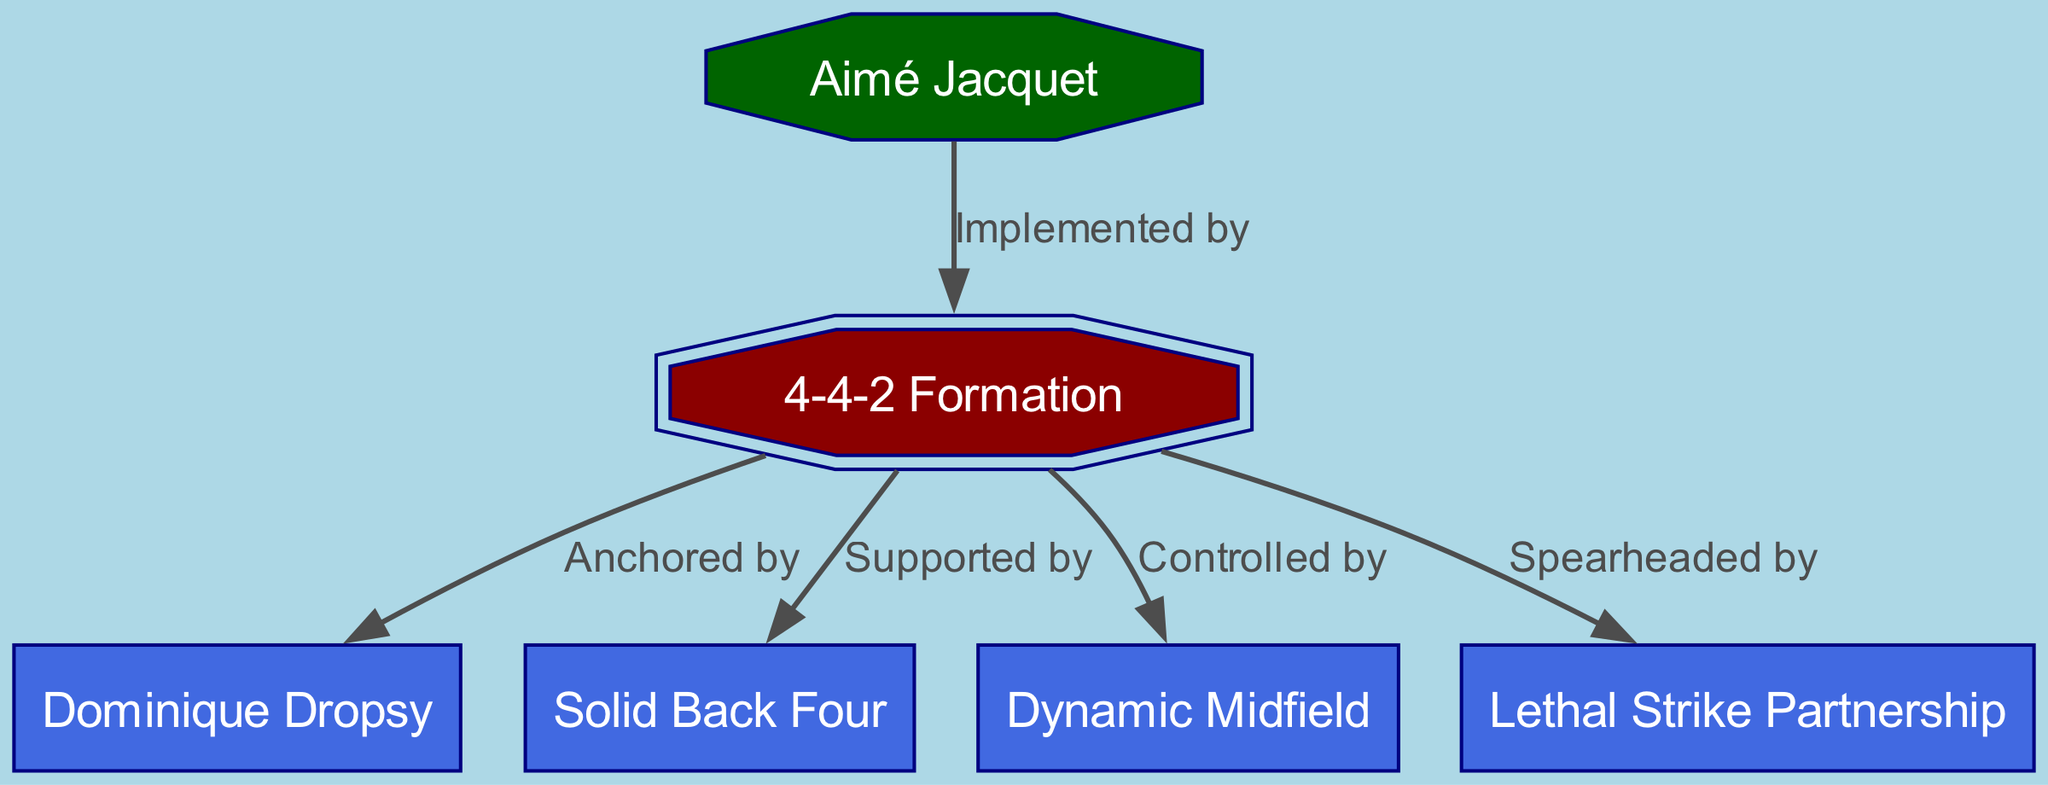What is the tactical formation of Bordeaux's 1984-85 championship-winning team? The diagram prominently indicates the tactical formation used by the team, which is shown as "4-4-2 Formation". There are no other formations mentioned, so it's the sole focus at the top of the graphic.
Answer: 4-4-2 Formation Who is the goalkeeper identified in the diagram? The diagram includes a node for the goalkeeper, labeled as "Dominique Dropsy", leading to the conclusion that he was the player in this position for the tactical setup.
Answer: Dominique Dropsy How many main components (nodes) are displayed in this tactical diagram? The diagram contains a total of six distinct nodes: one for the formation, one for the manager, and four for the team's playing positions. By counting these nodes, we arrive at the total.
Answer: 6 What role does Aimé Jacquet have in relation to the formation? In the diagram, Aimé Jacquet is connected to the formation with the label "Implemented by", indicating his leadership role in adopting and executing the tactical structure.
Answer: Implemented by What is the relationship between the Solid Back Four and the 4-4-2 Formation? The diagram indicates a directional edge from the formation to the "Solid Back Four" with the label "Supported by", which defines the nature of their connection; the back four players provide support to the formation.
Answer: Supported by Which aspect is controlled by the midfield in this tactical setup? According to the diagram, the node for "Dynamic Midfield" is linked to the "4-4-2 Formation" labeled as "Controlled by". This implies that the midfield plays a pivotal role in controlling the game.
Answer: Controlled by How many edges connect different components in the diagram? The diagram shows five directional edges that define the connections between nodes, representing the various relationships outlined in the tactical analysis of the team.
Answer: 5 What unique position does the "Lethal Strike Partnership" have concerning the attack? The connection from the "4-4-2 Formation" to "Lethal Strike Partnership" is labeled "Spearheaded by", indicating that the strike partnership is positioned at the forefront of the attacking strategy.
Answer: Spearheaded by 